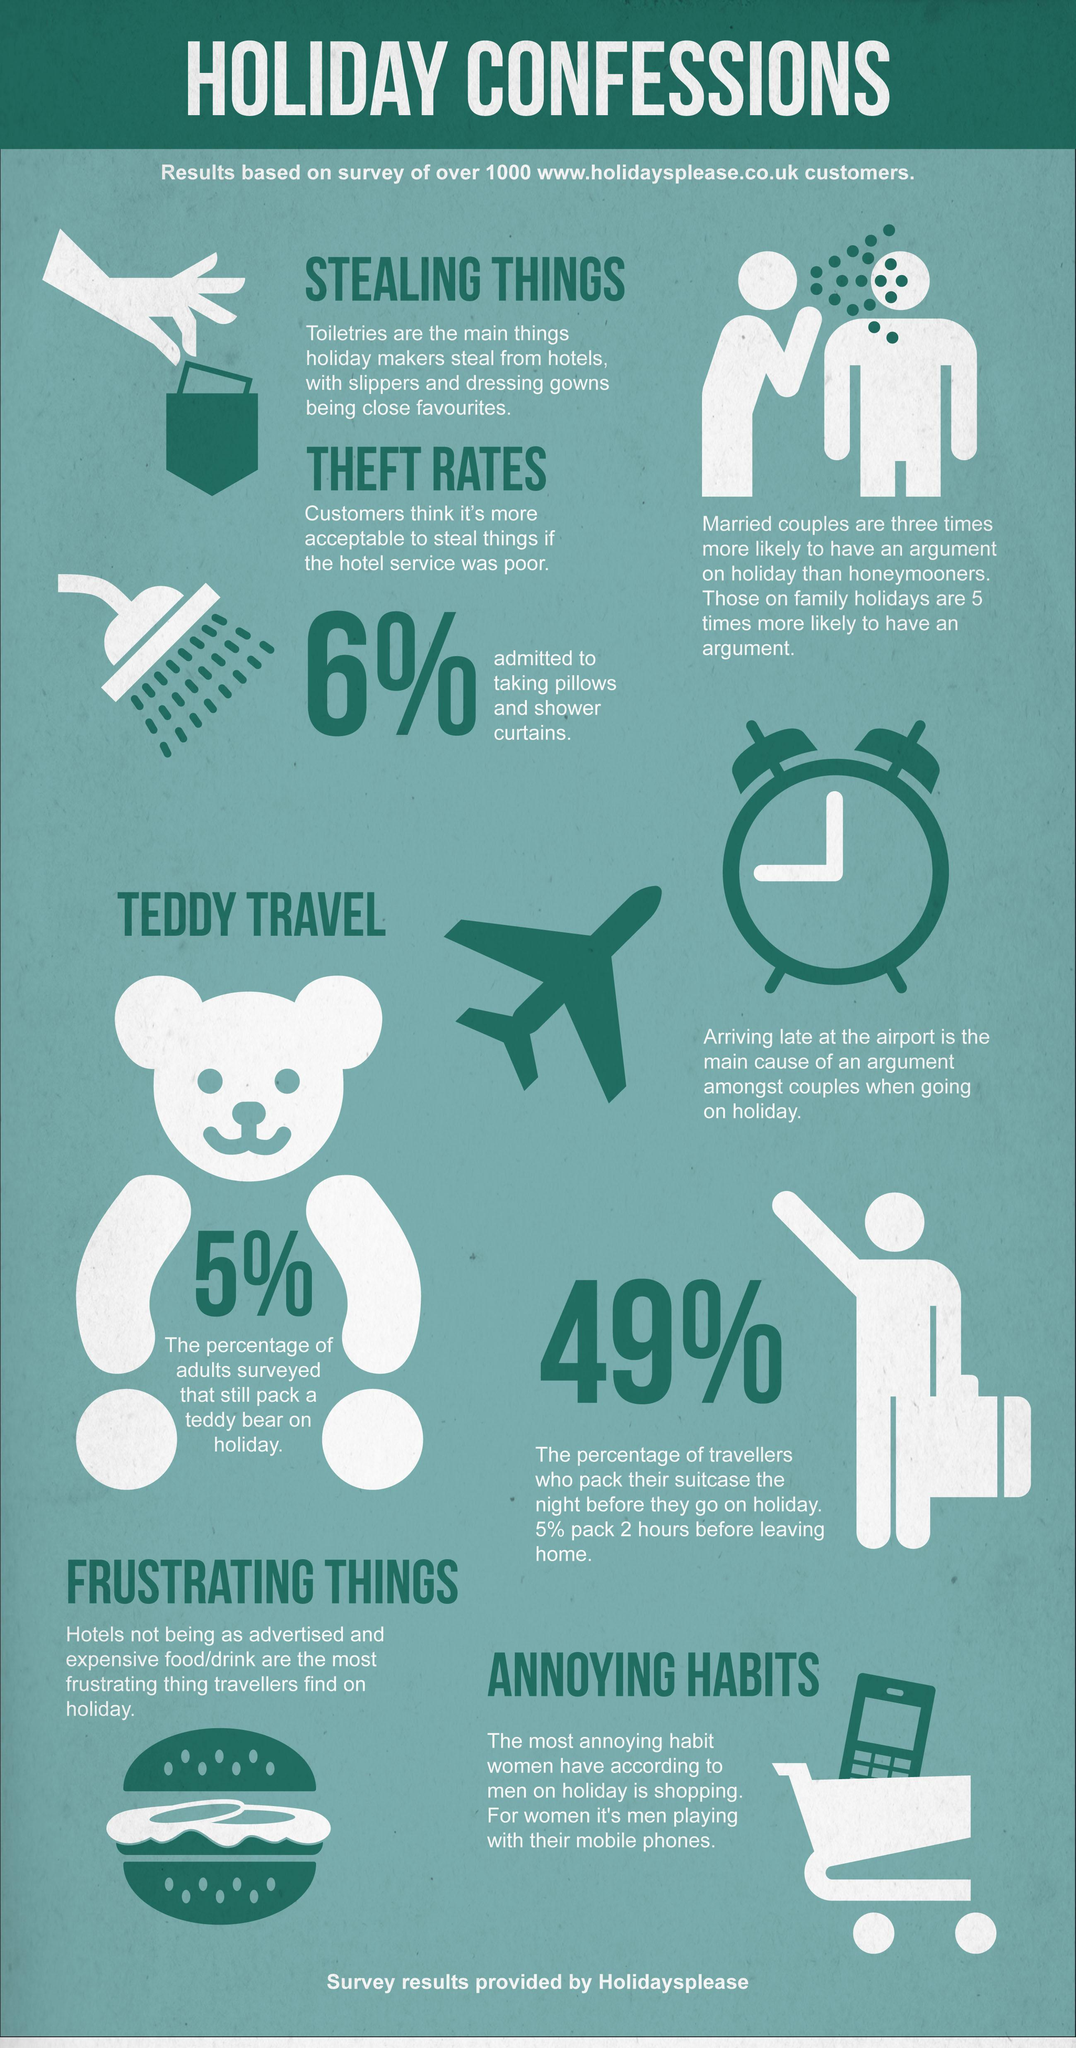What habit in females do males find annoying, while on a holiday ?
Answer the question with a short phrase. Shopping According to women, what annoying habits do men have while on a holiday? Playing with their mobile phones What toiletries are most stolen by holidaymakers ? Slippers and dressing gowns Who are most likely to have arguments on a holiday - honeymooners, married couples or those on family holidays ? Those on family holidays What was the primary reason for arguments between couples on a holiday ? Arriving late at the airport What percentage of adults carry their teddy bear with them on a holiday ? 5% How many images of aeroplanes are shown here ? 1 How many holidayers were reviewed for this report ? 1000 